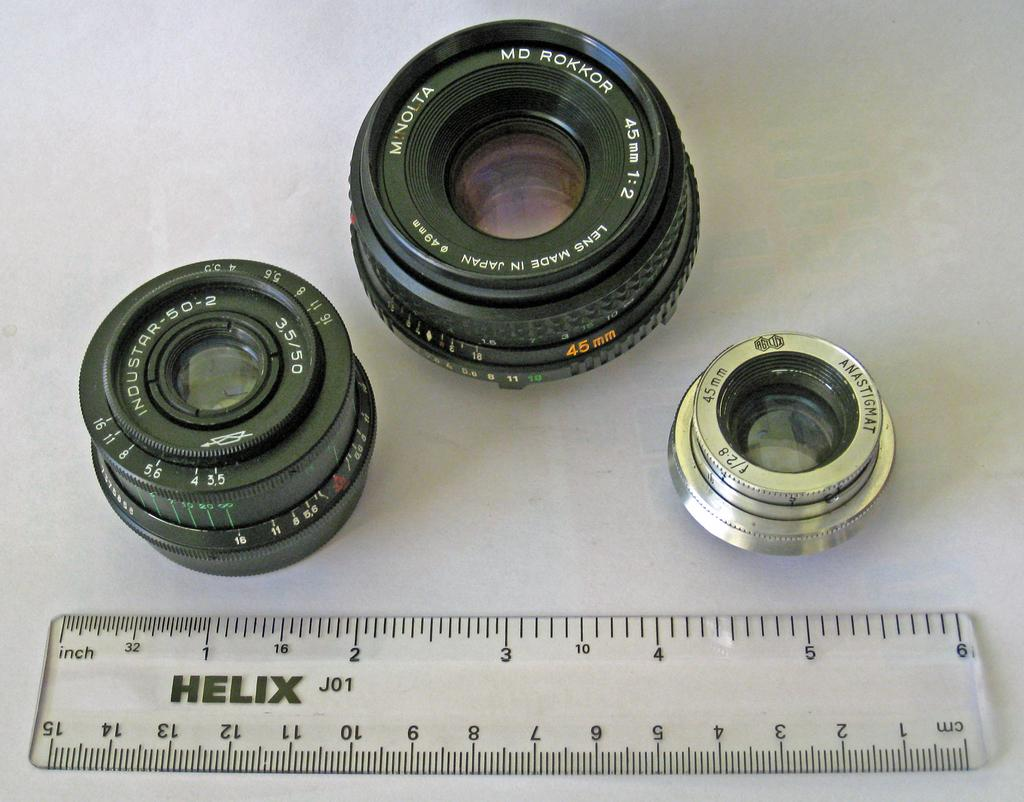<image>
Provide a brief description of the given image. A ruler that says Helix on it sits near some camera lenses. 